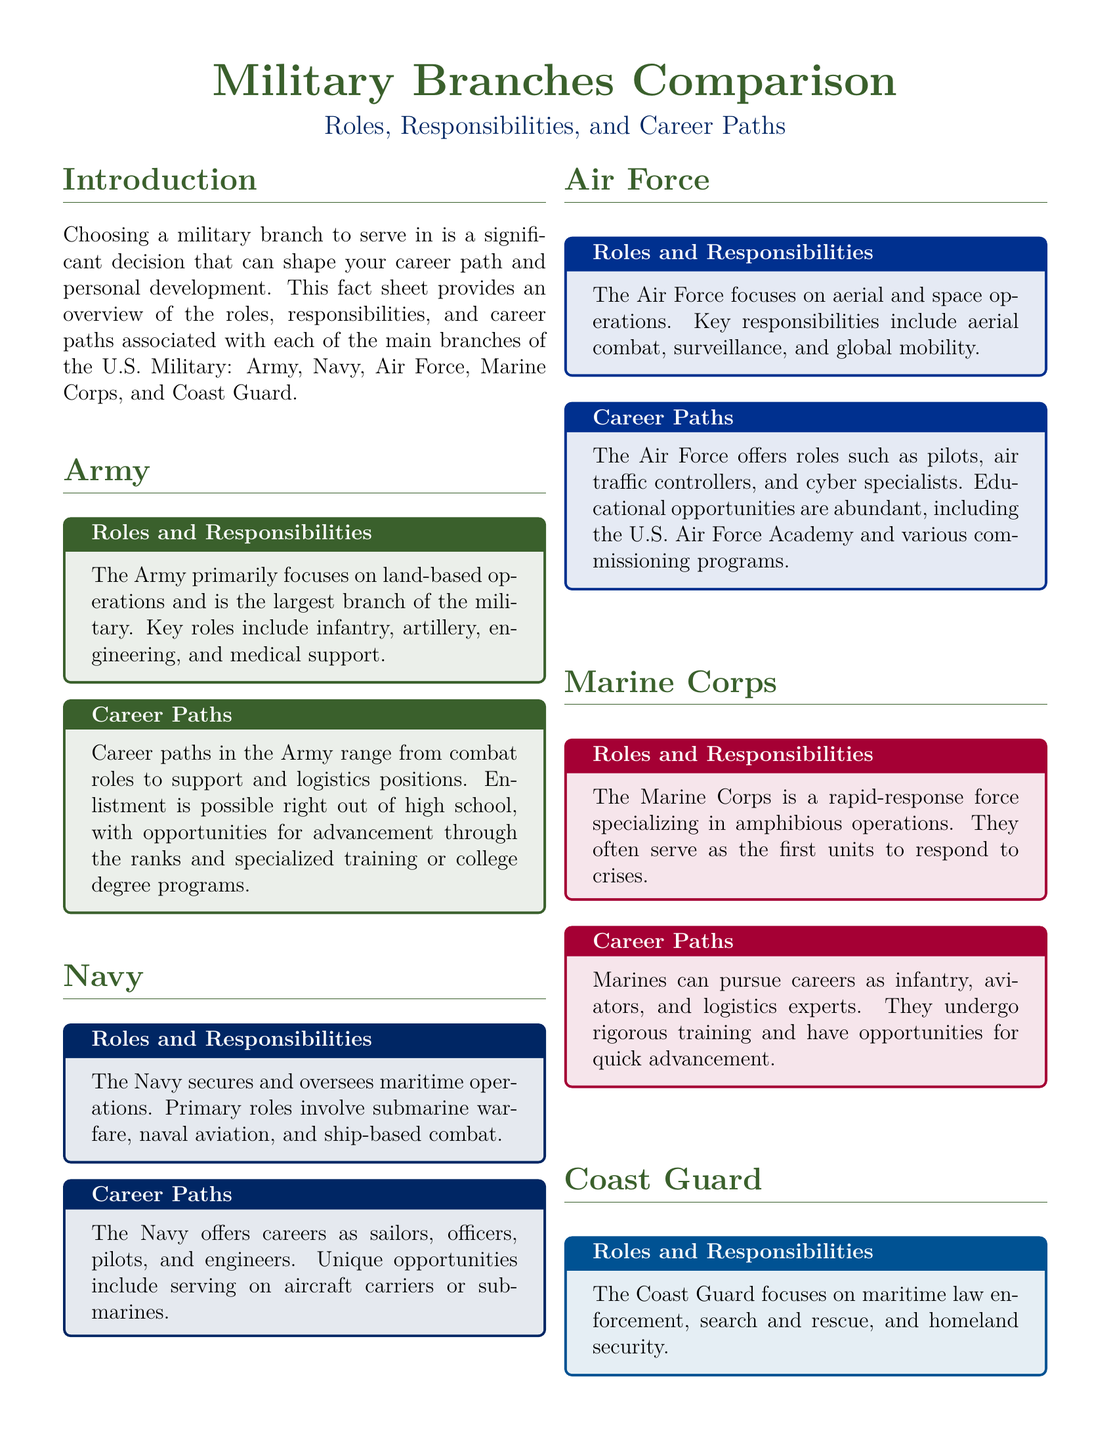What is the largest branch of the military? The document states that the Army is the largest branch of the military.
Answer: Army Which branch focuses on aerial and space operations? The document identifies the Air Force as the branch focusing on aerial and space operations.
Answer: Air Force What is a primary role of the Navy? The document mentions submarine warfare as a primary role of the Navy.
Answer: Submarine warfare How does one enlist in the Army? The document indicates that enlistment in the Army is possible right out of high school.
Answer: Right out of high school What are two roles available in the Coast Guard? The document lists navigation and law enforcement as roles in the Coast Guard.
Answer: Navigation, law enforcement Which branch serves as a rapid-response force? The document specifies that the Marine Corps is a rapid-response force.
Answer: Marine Corps What educational opportunities does the Air Force provide? The document describes abundant educational opportunities, including the U.S. Air Force Academy.
Answer: U.S. Air Force Academy What is emphasized about career advancement in the Marines? The document notes that the Marines have opportunities for quick advancement.
Answer: Quick advancement What does the Coast Guard primarily focus on? The document states that the Coast Guard focuses on maritime law enforcement, search and rescue, and homeland security.
Answer: Maritime law enforcement, search and rescue, homeland security 